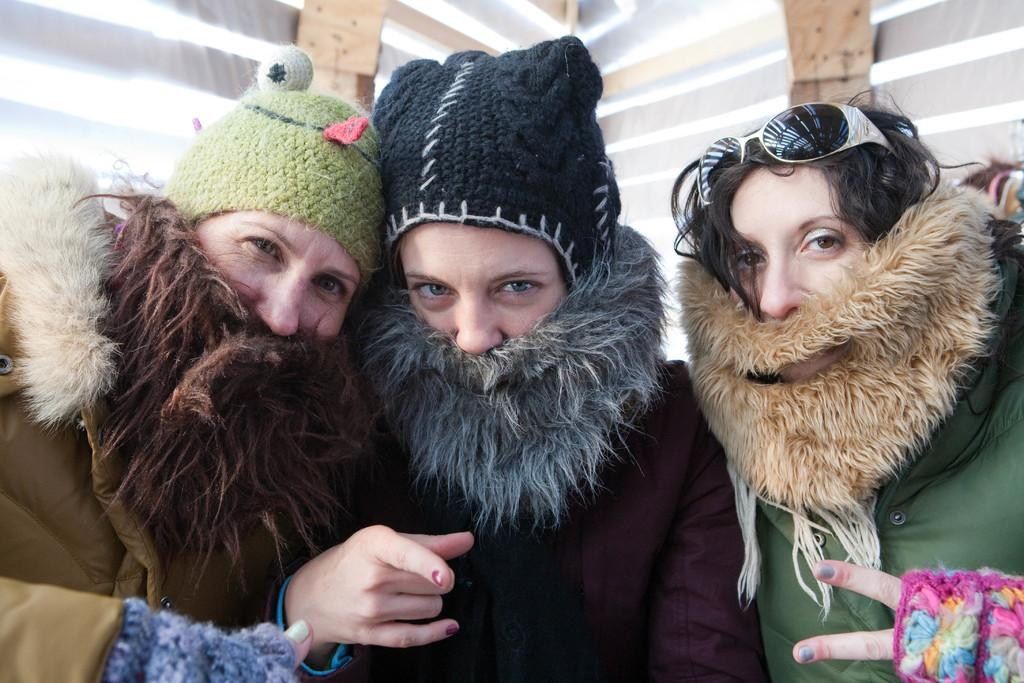How many people are present in the image? There are three persons in the image. What type of dog is sitting next to the persons in the image? There is no dog present in the image; it only features three persons. 